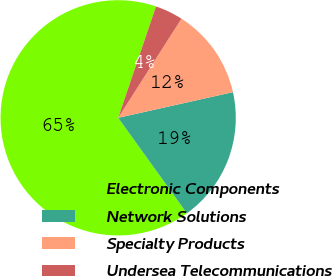<chart> <loc_0><loc_0><loc_500><loc_500><pie_chart><fcel>Electronic Components<fcel>Network Solutions<fcel>Specialty Products<fcel>Undersea Telecommunications<nl><fcel>65.13%<fcel>18.58%<fcel>12.45%<fcel>3.83%<nl></chart> 